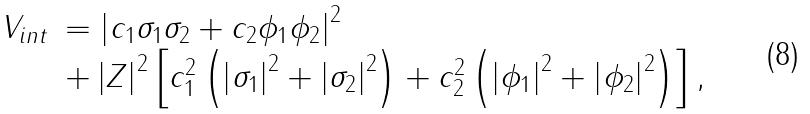<formula> <loc_0><loc_0><loc_500><loc_500>\begin{array} { l l } V _ { i n t } & = \left | c _ { 1 } \sigma _ { 1 } \sigma _ { 2 } + c _ { 2 } \phi _ { 1 } \phi _ { 2 } \right | ^ { 2 } \\ & + \left | Z \right | ^ { 2 } \left [ c _ { 1 } ^ { 2 } \left ( \left | \sigma _ { 1 } \right | ^ { 2 } + \left | \sigma _ { 2 } \right | ^ { 2 } \right ) + c _ { 2 } ^ { 2 } \left ( \left | \phi _ { 1 } \right | ^ { 2 } + \left | \phi _ { 2 } \right | ^ { 2 } \right ) \right ] , \end{array}</formula> 